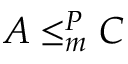<formula> <loc_0><loc_0><loc_500><loc_500>A \leq _ { m } ^ { P } C</formula> 